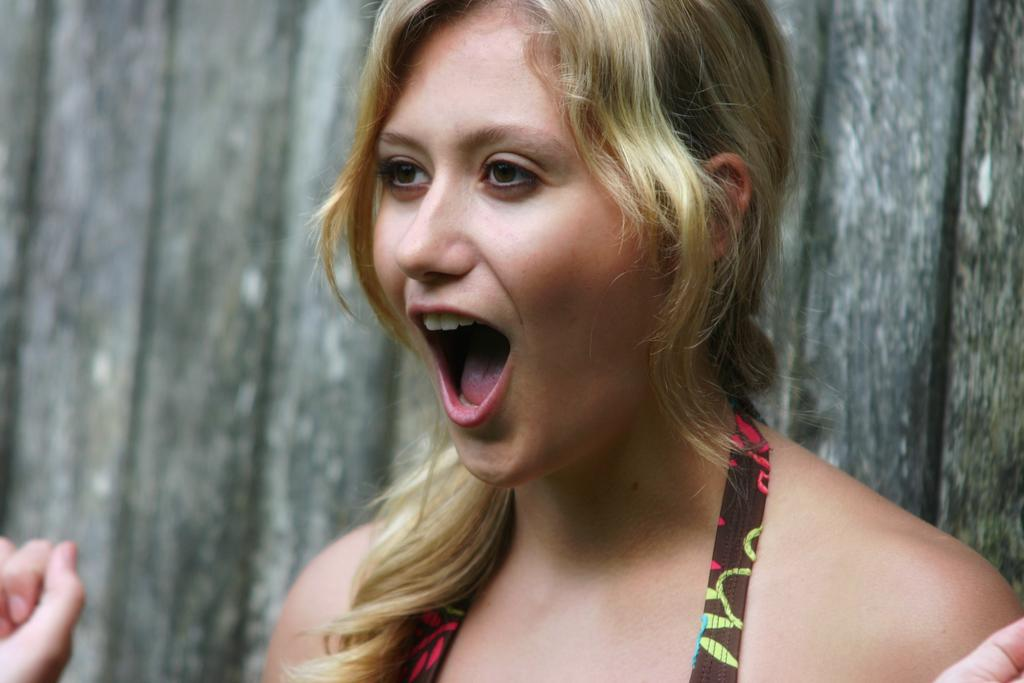What is the primary subject in the image? There is a woman standing in the image. Can you describe the background or setting of the image? There is a wooden wall in the image. What type of metal is used to make the yoke in the image? There is no yoke present in the image, so it is not possible to determine what type of metal might be used. 